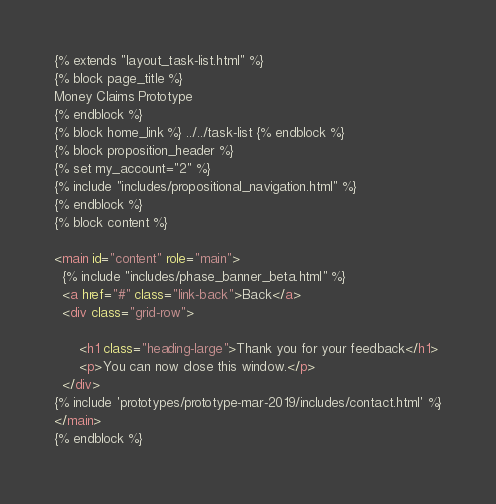Convert code to text. <code><loc_0><loc_0><loc_500><loc_500><_HTML_>{% extends "layout_task-list.html" %}
{% block page_title %}
Money Claims Prototype
{% endblock %}
{% block home_link %} ../../task-list {% endblock %}
{% block proposition_header %}
{% set my_account="2" %}
{% include "includes/propositional_navigation.html" %}
{% endblock %}
{% block content %}

<main id="content" role="main">
  {% include "includes/phase_banner_beta.html" %}
  <a href="#" class="link-back">Back</a>
  <div class="grid-row">

      <h1 class="heading-large">Thank you for your feedback</h1>
      <p>You can now close this window.</p>
  </div>
{% include 'prototypes/prototype-mar-2019/includes/contact.html' %}
</main>
{% endblock %}</code> 